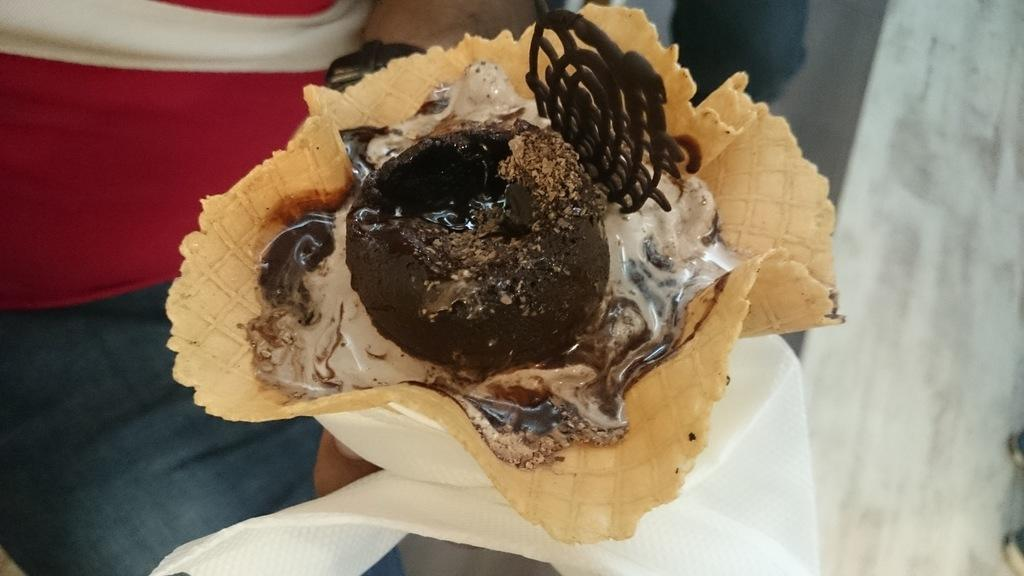What part of a person can be seen in the image? There is a hand of a person in the image. What is the main object in the image? There is an ice cream in the image. What colors are present on the ice cream? The ice cream has white, black, and green colors. What can be used for cleaning or wiping in the image? There are tissue papers in the image. What degree does the person in the image have? There is no information about the person's degree in the image. What type of voice can be heard in the image? The image is silent, so there is no voice present. 